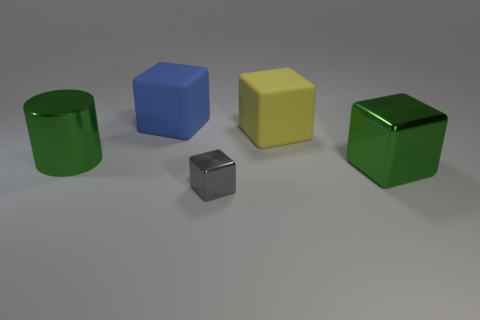Subtract all gray metallic blocks. How many blocks are left? 3 Add 4 tiny cyan metallic things. How many objects exist? 9 Subtract all blue blocks. How many blocks are left? 3 Subtract 3 blocks. How many blocks are left? 1 Subtract all red balls. How many yellow cylinders are left? 0 Subtract all green metal objects. Subtract all big cyan metal spheres. How many objects are left? 3 Add 1 small gray shiny things. How many small gray shiny things are left? 2 Add 2 small blue spheres. How many small blue spheres exist? 2 Subtract 1 yellow blocks. How many objects are left? 4 Subtract all cylinders. How many objects are left? 4 